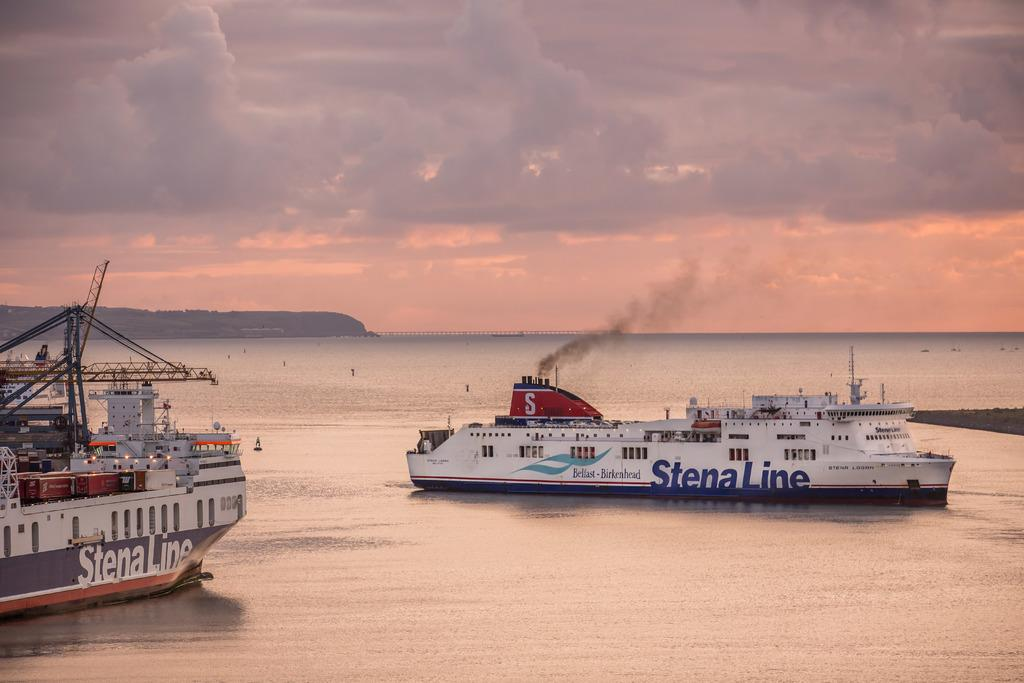What can be seen in the image related to transportation? There are two large ships in the image. Where are the ships located? The ships are sailing on the sea. Can you describe any specific activity of one of the ships? One of the ships is emitting smoke through its pipes. How would you describe the weather conditions in the image? The weather in the image is pleasant. What type of flesh can be seen on the ships in the image? There is no flesh present on the ships in the image; they are large vessels made of metal and other materials. 